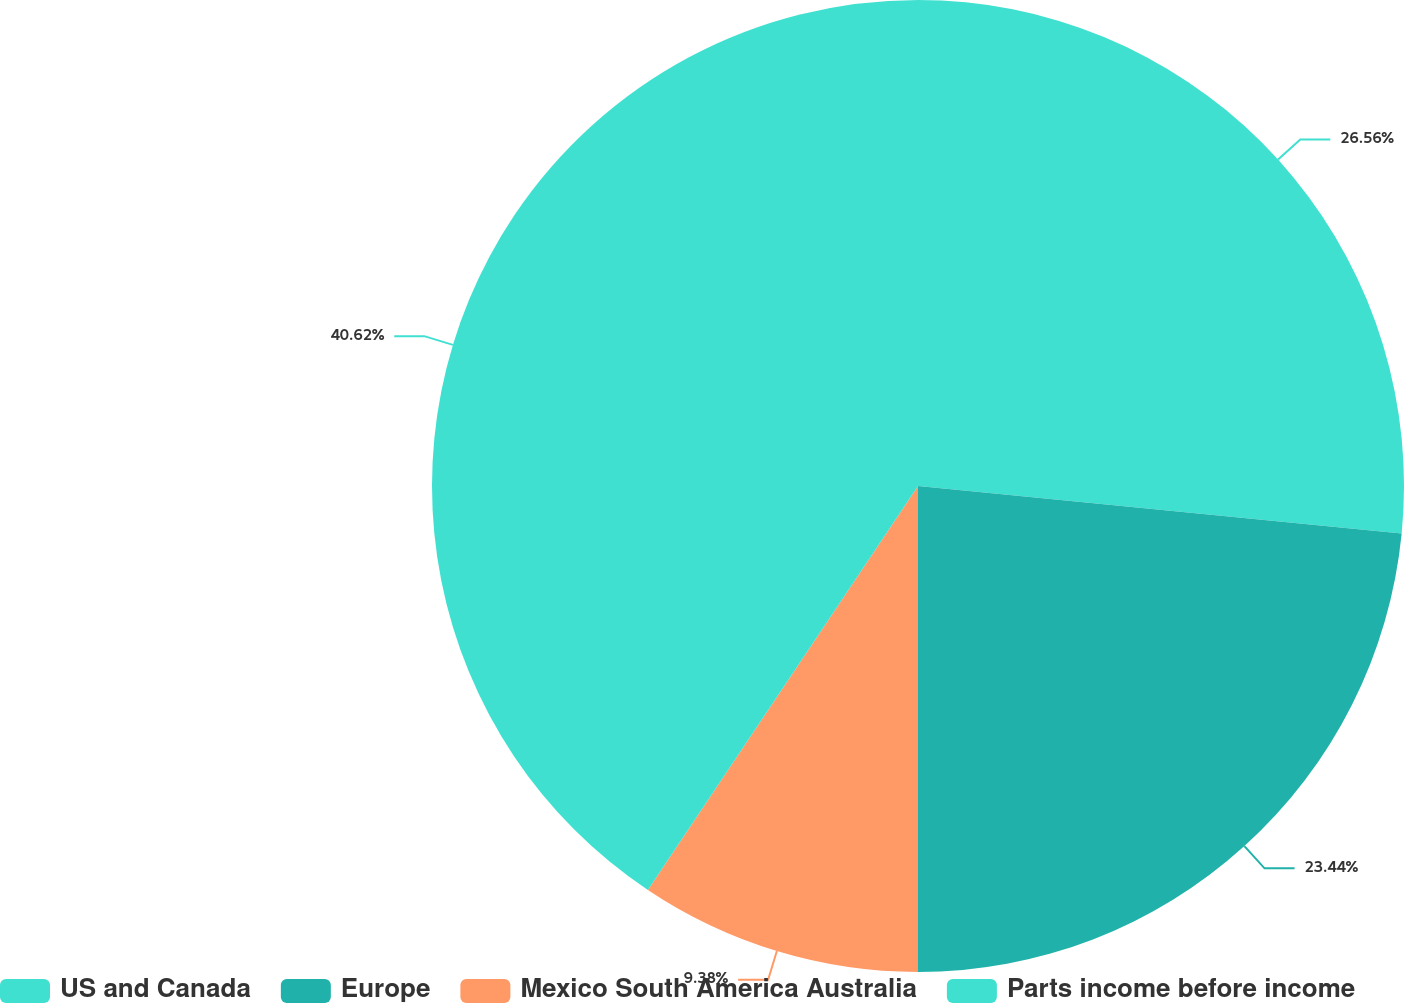Convert chart. <chart><loc_0><loc_0><loc_500><loc_500><pie_chart><fcel>US and Canada<fcel>Europe<fcel>Mexico South America Australia<fcel>Parts income before income<nl><fcel>26.56%<fcel>23.44%<fcel>9.38%<fcel>40.62%<nl></chart> 